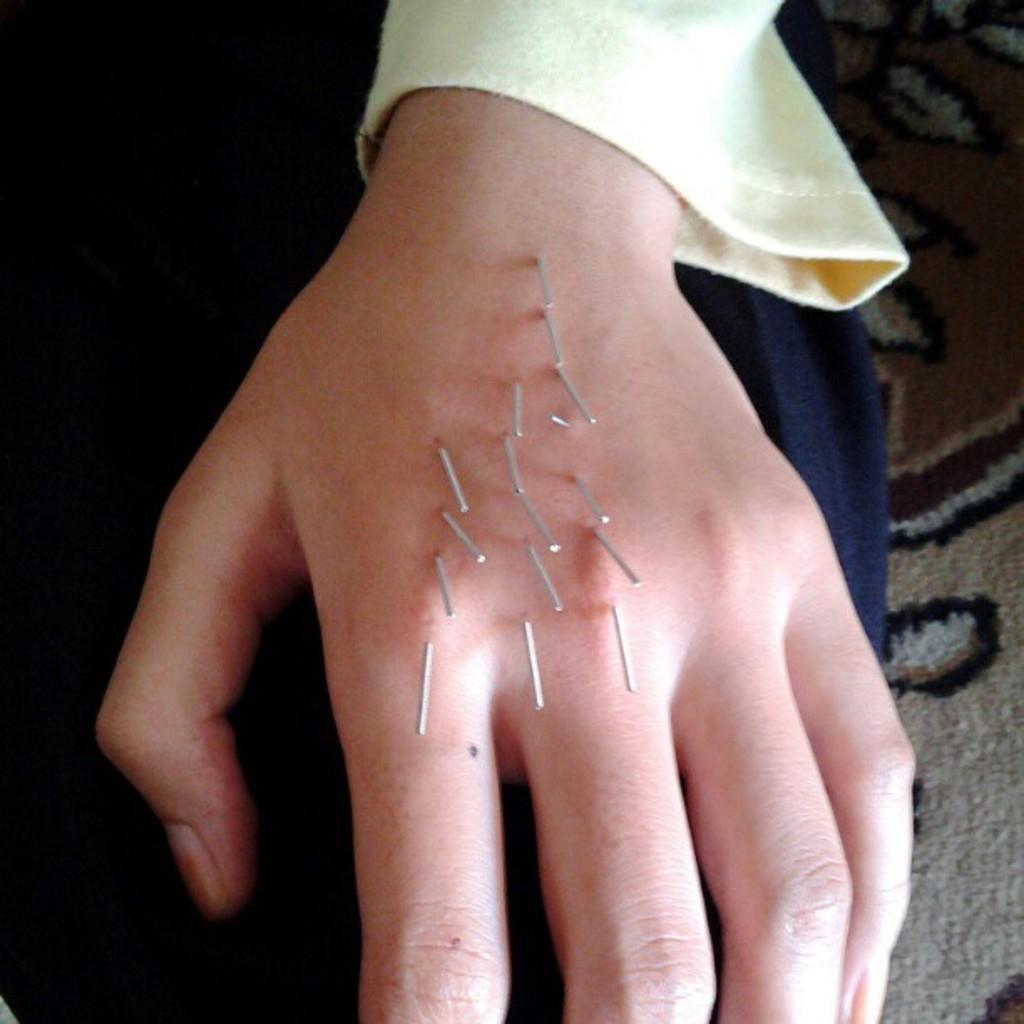What is the main subject of the image? The main subject of the image is a human hand. What can be seen on the hand in the image? There are needles on the hand in the image. What is visible in the background of the image? The background of the image includes a cloth. What color is the cloth in the image? The cloth is in cream color. How many pies are being held by the hand in the image? There are no pies present in the image; the hand has needles on it. What is the low way to approach the hand in the image? There is no need to approach the hand in the image, as it is a still image. 